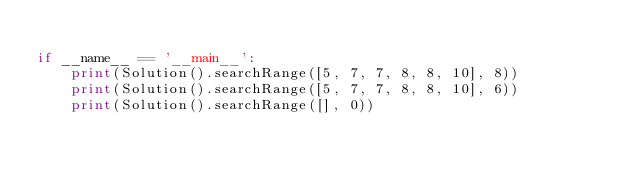<code> <loc_0><loc_0><loc_500><loc_500><_Python_>
if __name__ == '__main__':
    print(Solution().searchRange([5, 7, 7, 8, 8, 10], 8))
    print(Solution().searchRange([5, 7, 7, 8, 8, 10], 6))
    print(Solution().searchRange([], 0))
</code> 